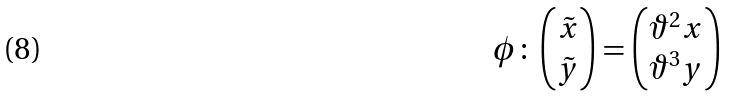Convert formula to latex. <formula><loc_0><loc_0><loc_500><loc_500>\phi \colon \begin{pmatrix} \tilde { x } \\ \tilde { y } \end{pmatrix} = \begin{pmatrix} \vartheta ^ { 2 } x \\ \vartheta ^ { 3 } { y } \end{pmatrix}</formula> 